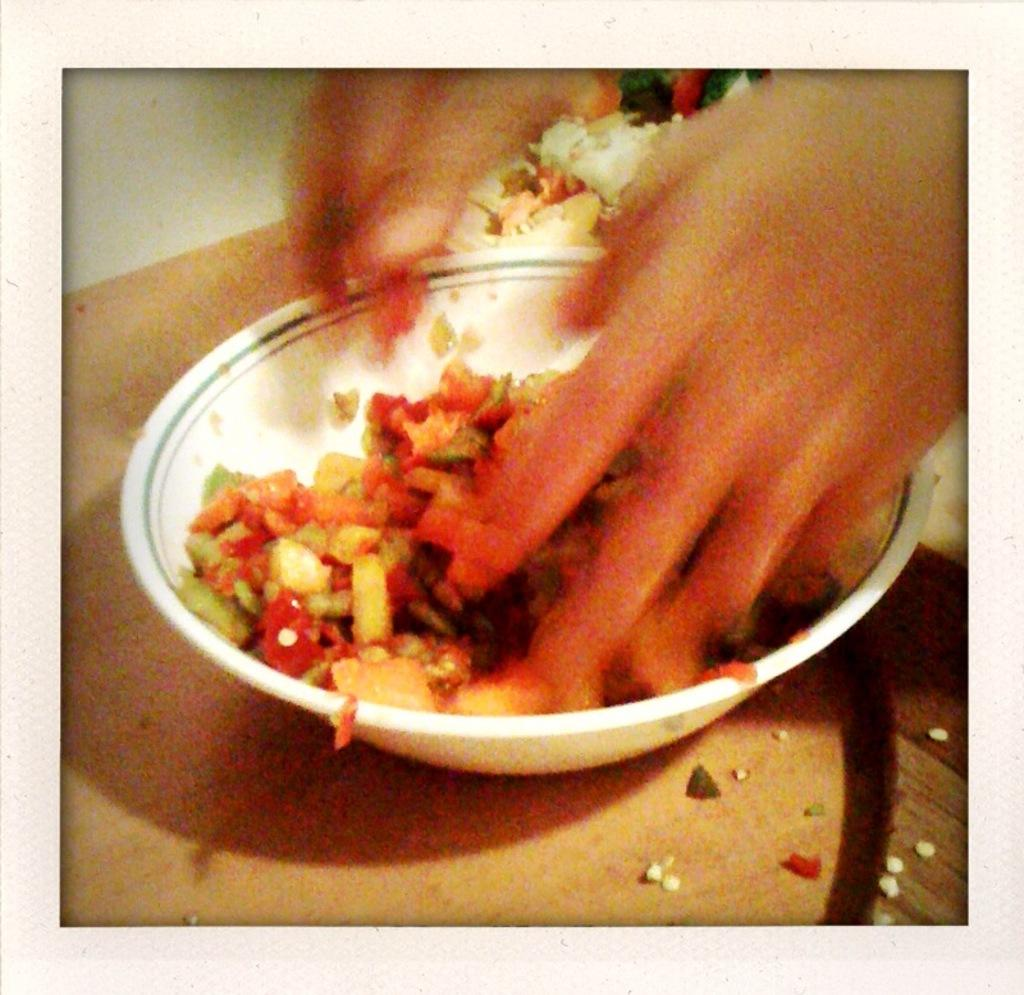What part of a person can be seen in the image? There is a person's hand in the image. How would you describe the appearance of the hand? The hand is slightly blurred. What object is the hand interacting with in the image? There is a bowl in the image. What is inside the bowl? The bowl contains a food item. What type of surface is the bowl placed on? The bowl is placed on a wooden surface. What type of cherries are being traded in the image? There is no mention of cherries or trading in the image; it only features a person's hand, a bowl, and a food item. 